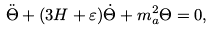Convert formula to latex. <formula><loc_0><loc_0><loc_500><loc_500>\ddot { \Theta } + ( 3 H + \varepsilon ) \dot { \Theta } + m _ { a } ^ { 2 } \Theta = 0 ,</formula> 